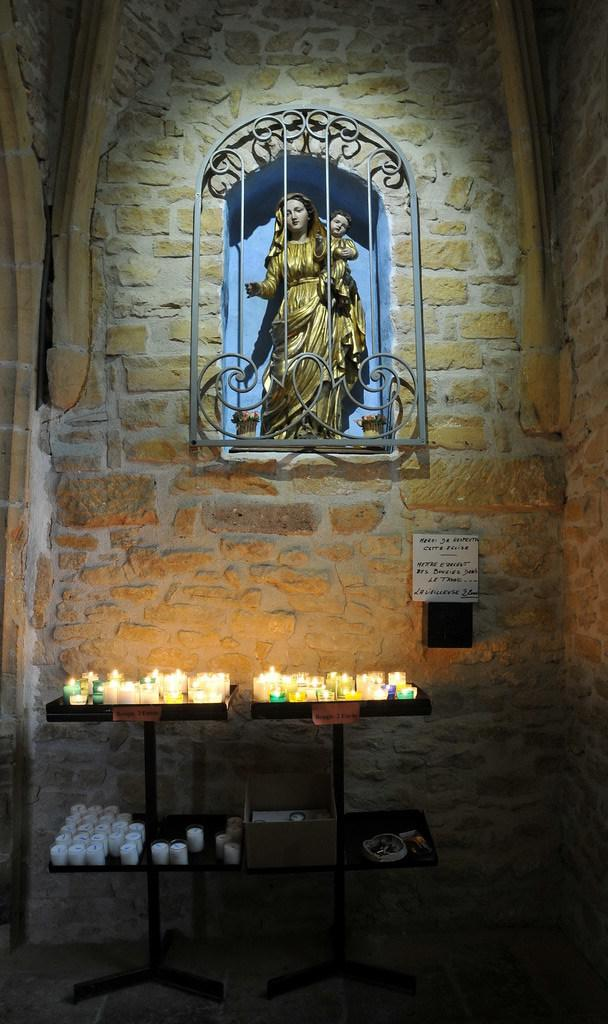What is the main subject in the middle of the image? There are statues in the middle of the image. Where are the statues located? The statues are on a wall. What other objects can be seen in the image? There are candles on a table in the image. What type of list is hanging from the rod near the statues? There is no list or rod present in the image; it only features statues on a wall and candles on a table. 